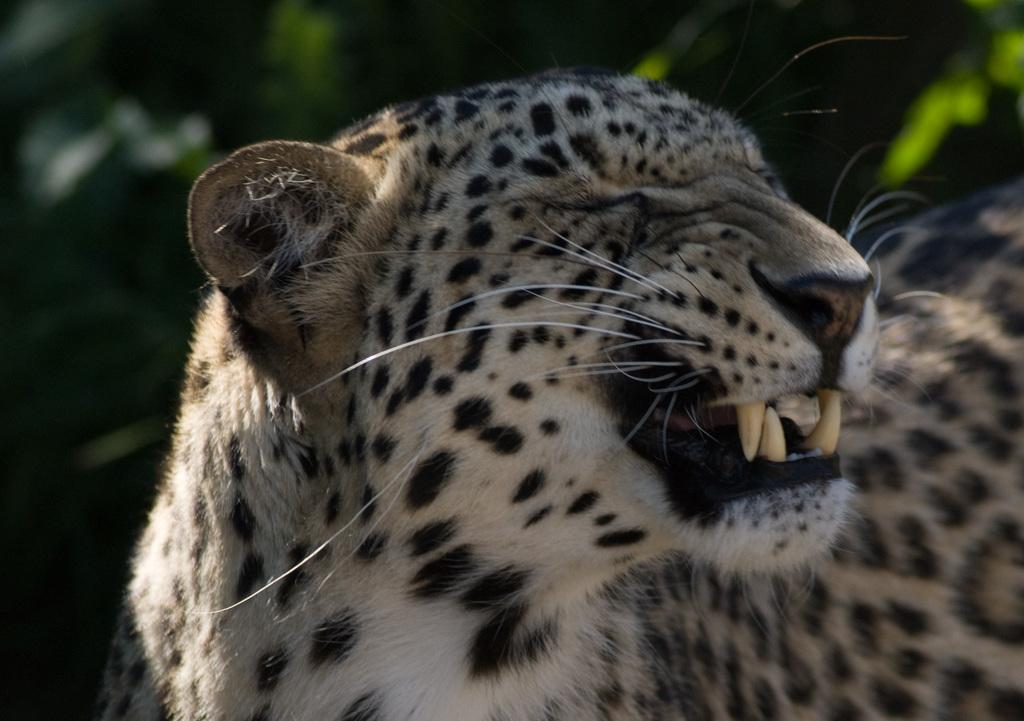What animal is in the center of the image? There is a cheetah in the center of the image. What can be seen in the background of the image? There are trees in the background of the image. What type of curve can be seen in the cheetah's pocket in the image? There is no curve or pocket present on the cheetah in the image, as it is a wild animal and does not have clothing or pockets. 